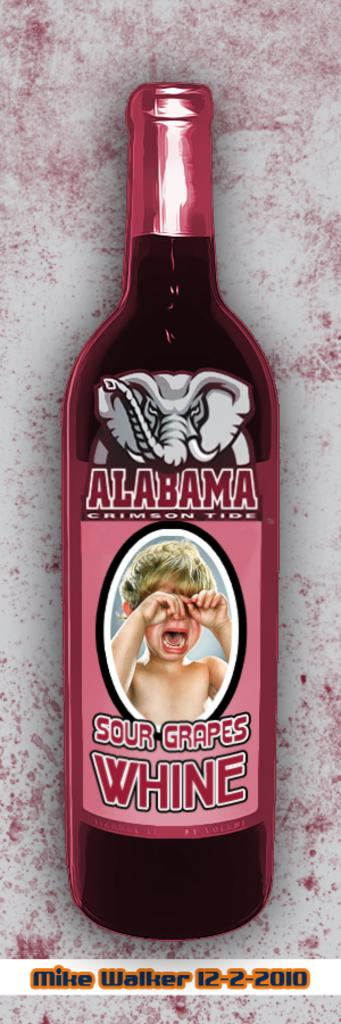<image>
Render a clear and concise summary of the photo. A crying child is found on the label of Sour Grapes wine. 